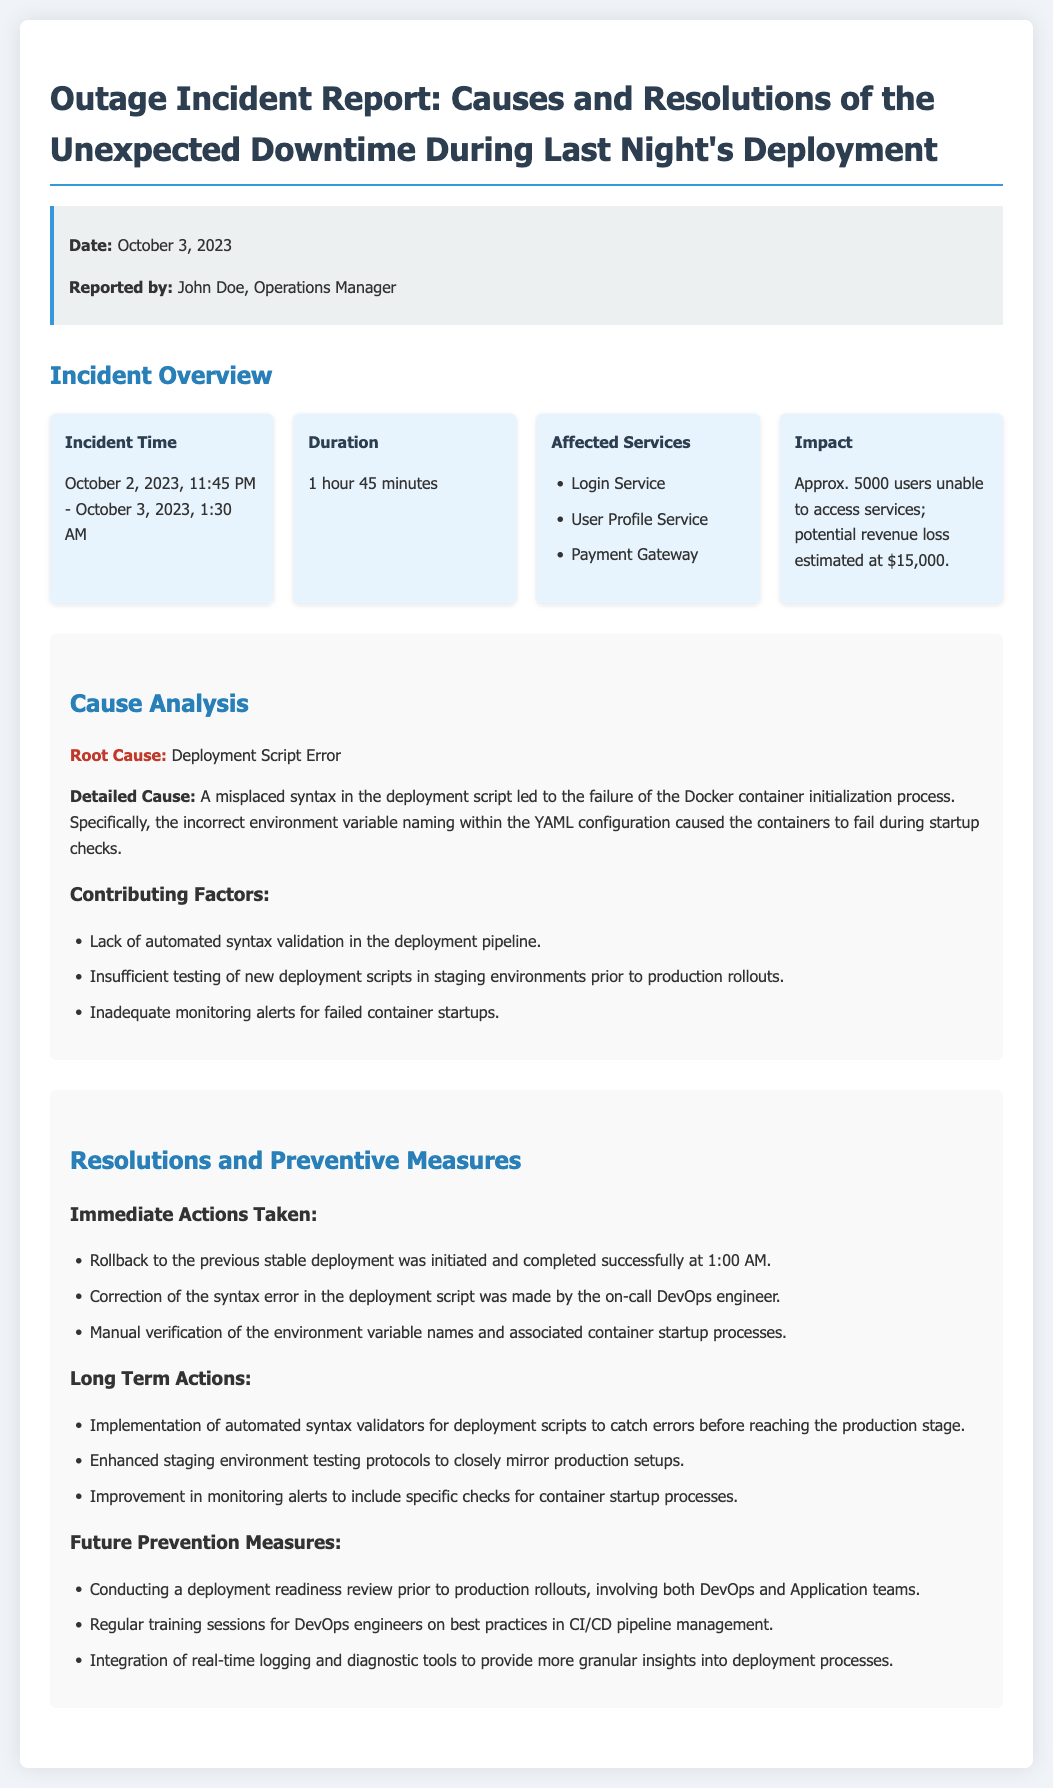What was the incident time? The incident time refers to the duration during which the outage occurred, which is listed as October 2, 2023, 11:45 PM - October 3, 2023, 1:30 AM.
Answer: October 2, 2023, 11:45 PM - October 3, 2023, 1:30 AM How long did the outage last? The duration of the outage is specified in the document as 1 hour 45 minutes.
Answer: 1 hour 45 minutes What services were affected? The document lists affected services that include Login Service, User Profile Service, and Payment Gateway.
Answer: Login Service, User Profile Service, Payment Gateway What was the root cause of the outage? The root cause of the outage is explicitly stated, indicating what led to the downtime.
Answer: Deployment Script Error What corrective action was taken first? The immediate action taken to resolve the incident is mentioned in the resolutions section, indicating the first step taken after discovering the issue.
Answer: Rollback to the previous stable deployment What was the estimated revenue loss? The document mentions an estimated revenue loss due to the outage affecting approximately 5000 users.
Answer: $15,000 What will be implemented for future prevention? The report outlines long-term and future prevention measures, providing insights on upcoming strategies to avoid similar incidents.
Answer: Conducting a deployment readiness review What is the reporting date of the incident? The report specifies the date when the outage incident was documented, which is crucial for understanding the timeline of events.
Answer: October 3, 2023 Who reported the incident? The report includes the name of the person who documented the incident, relevant for accountability and communication.
Answer: John Doe, Operations Manager 